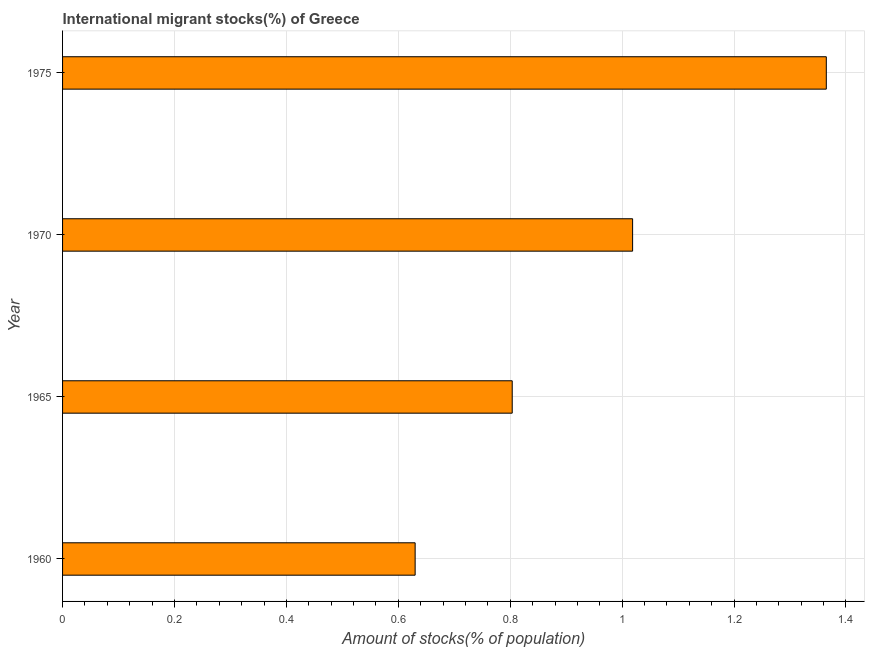Does the graph contain any zero values?
Your response must be concise. No. Does the graph contain grids?
Give a very brief answer. Yes. What is the title of the graph?
Offer a very short reply. International migrant stocks(%) of Greece. What is the label or title of the X-axis?
Your answer should be compact. Amount of stocks(% of population). What is the number of international migrant stocks in 1970?
Give a very brief answer. 1.02. Across all years, what is the maximum number of international migrant stocks?
Offer a terse response. 1.36. Across all years, what is the minimum number of international migrant stocks?
Offer a very short reply. 0.63. In which year was the number of international migrant stocks maximum?
Ensure brevity in your answer.  1975. In which year was the number of international migrant stocks minimum?
Your answer should be very brief. 1960. What is the sum of the number of international migrant stocks?
Your answer should be compact. 3.82. What is the difference between the number of international migrant stocks in 1960 and 1965?
Give a very brief answer. -0.17. What is the average number of international migrant stocks per year?
Keep it short and to the point. 0.95. What is the median number of international migrant stocks?
Make the answer very short. 0.91. What is the ratio of the number of international migrant stocks in 1960 to that in 1975?
Give a very brief answer. 0.46. What is the difference between the highest and the second highest number of international migrant stocks?
Provide a succinct answer. 0.35. What is the difference between the highest and the lowest number of international migrant stocks?
Your response must be concise. 0.73. How many years are there in the graph?
Ensure brevity in your answer.  4. What is the difference between two consecutive major ticks on the X-axis?
Make the answer very short. 0.2. What is the Amount of stocks(% of population) of 1960?
Ensure brevity in your answer.  0.63. What is the Amount of stocks(% of population) in 1965?
Provide a short and direct response. 0.8. What is the Amount of stocks(% of population) of 1970?
Give a very brief answer. 1.02. What is the Amount of stocks(% of population) of 1975?
Your answer should be very brief. 1.36. What is the difference between the Amount of stocks(% of population) in 1960 and 1965?
Provide a short and direct response. -0.17. What is the difference between the Amount of stocks(% of population) in 1960 and 1970?
Provide a short and direct response. -0.39. What is the difference between the Amount of stocks(% of population) in 1960 and 1975?
Offer a very short reply. -0.73. What is the difference between the Amount of stocks(% of population) in 1965 and 1970?
Ensure brevity in your answer.  -0.22. What is the difference between the Amount of stocks(% of population) in 1965 and 1975?
Your answer should be very brief. -0.56. What is the difference between the Amount of stocks(% of population) in 1970 and 1975?
Make the answer very short. -0.35. What is the ratio of the Amount of stocks(% of population) in 1960 to that in 1965?
Provide a succinct answer. 0.78. What is the ratio of the Amount of stocks(% of population) in 1960 to that in 1970?
Keep it short and to the point. 0.62. What is the ratio of the Amount of stocks(% of population) in 1960 to that in 1975?
Make the answer very short. 0.46. What is the ratio of the Amount of stocks(% of population) in 1965 to that in 1970?
Offer a very short reply. 0.79. What is the ratio of the Amount of stocks(% of population) in 1965 to that in 1975?
Keep it short and to the point. 0.59. What is the ratio of the Amount of stocks(% of population) in 1970 to that in 1975?
Provide a succinct answer. 0.75. 